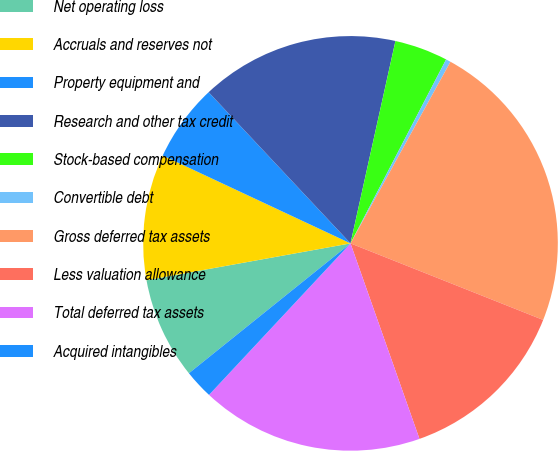Convert chart to OTSL. <chart><loc_0><loc_0><loc_500><loc_500><pie_chart><fcel>Net operating loss<fcel>Accruals and reserves not<fcel>Property equipment and<fcel>Research and other tax credit<fcel>Stock-based compensation<fcel>Convertible debt<fcel>Gross deferred tax assets<fcel>Less valuation allowance<fcel>Total deferred tax assets<fcel>Acquired intangibles<nl><fcel>7.93%<fcel>9.81%<fcel>6.04%<fcel>15.47%<fcel>4.15%<fcel>0.38%<fcel>23.01%<fcel>13.58%<fcel>17.35%<fcel>2.27%<nl></chart> 